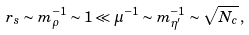<formula> <loc_0><loc_0><loc_500><loc_500>r _ { s } \sim m _ { \rho } ^ { - 1 } \sim 1 \ll \mu ^ { - 1 } \sim m _ { \eta ^ { \prime } } ^ { - 1 } \sim \sqrt { N _ { c } } \, ,</formula> 